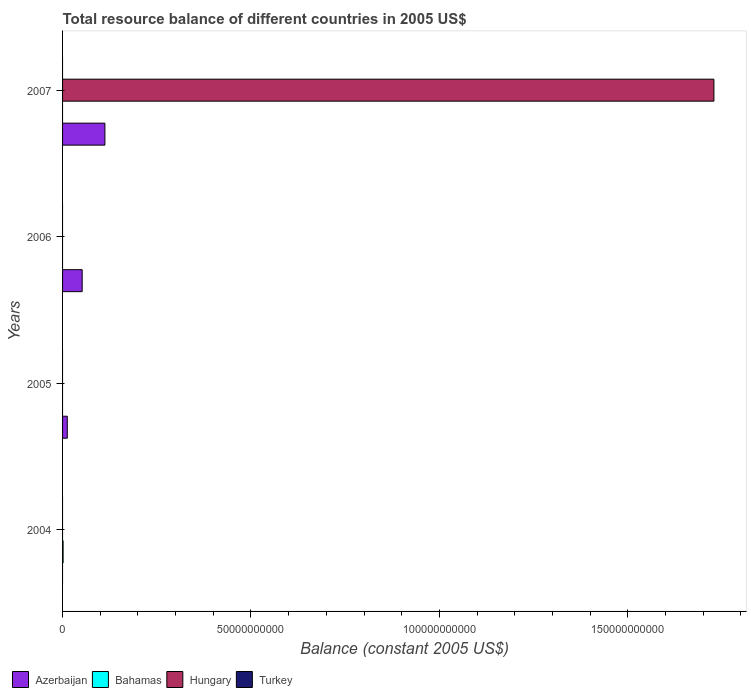How many different coloured bars are there?
Ensure brevity in your answer.  3. Are the number of bars per tick equal to the number of legend labels?
Offer a terse response. No. What is the label of the 1st group of bars from the top?
Provide a succinct answer. 2007. In how many cases, is the number of bars for a given year not equal to the number of legend labels?
Keep it short and to the point. 4. What is the total resource balance in Bahamas in 2004?
Keep it short and to the point. 1.42e+08. Across all years, what is the maximum total resource balance in Bahamas?
Give a very brief answer. 1.42e+08. What is the total total resource balance in Hungary in the graph?
Provide a short and direct response. 1.73e+11. What is the difference between the total resource balance in Azerbaijan in 2005 and that in 2007?
Provide a succinct answer. -9.98e+09. What is the difference between the total resource balance in Azerbaijan in 2004 and the total resource balance in Bahamas in 2005?
Provide a succinct answer. 0. What is the average total resource balance in Azerbaijan per year?
Give a very brief answer. 4.42e+09. In the year 2007, what is the difference between the total resource balance in Azerbaijan and total resource balance in Hungary?
Your answer should be very brief. -1.62e+11. In how many years, is the total resource balance in Azerbaijan greater than 50000000000 US$?
Your answer should be very brief. 0. What is the difference between the highest and the second highest total resource balance in Azerbaijan?
Give a very brief answer. 6.03e+09. What is the difference between the highest and the lowest total resource balance in Azerbaijan?
Your response must be concise. 1.12e+1. In how many years, is the total resource balance in Azerbaijan greater than the average total resource balance in Azerbaijan taken over all years?
Your response must be concise. 2. Is it the case that in every year, the sum of the total resource balance in Bahamas and total resource balance in Hungary is greater than the sum of total resource balance in Azerbaijan and total resource balance in Turkey?
Ensure brevity in your answer.  No. Is it the case that in every year, the sum of the total resource balance in Azerbaijan and total resource balance in Bahamas is greater than the total resource balance in Turkey?
Provide a short and direct response. Yes. Are all the bars in the graph horizontal?
Ensure brevity in your answer.  Yes. How many years are there in the graph?
Your response must be concise. 4. Are the values on the major ticks of X-axis written in scientific E-notation?
Your response must be concise. No. Does the graph contain any zero values?
Provide a succinct answer. Yes. Where does the legend appear in the graph?
Offer a very short reply. Bottom left. How many legend labels are there?
Make the answer very short. 4. How are the legend labels stacked?
Your response must be concise. Horizontal. What is the title of the graph?
Offer a very short reply. Total resource balance of different countries in 2005 US$. Does "Norway" appear as one of the legend labels in the graph?
Your answer should be compact. No. What is the label or title of the X-axis?
Offer a very short reply. Balance (constant 2005 US$). What is the Balance (constant 2005 US$) of Bahamas in 2004?
Your response must be concise. 1.42e+08. What is the Balance (constant 2005 US$) of Azerbaijan in 2005?
Provide a short and direct response. 1.26e+09. What is the Balance (constant 2005 US$) of Bahamas in 2005?
Keep it short and to the point. 0. What is the Balance (constant 2005 US$) in Hungary in 2005?
Your answer should be compact. 0. What is the Balance (constant 2005 US$) of Turkey in 2005?
Keep it short and to the point. 0. What is the Balance (constant 2005 US$) of Azerbaijan in 2006?
Your answer should be very brief. 5.20e+09. What is the Balance (constant 2005 US$) of Hungary in 2006?
Ensure brevity in your answer.  0. What is the Balance (constant 2005 US$) of Turkey in 2006?
Your answer should be very brief. 0. What is the Balance (constant 2005 US$) of Azerbaijan in 2007?
Provide a succinct answer. 1.12e+1. What is the Balance (constant 2005 US$) of Hungary in 2007?
Keep it short and to the point. 1.73e+11. What is the Balance (constant 2005 US$) in Turkey in 2007?
Offer a terse response. 0. Across all years, what is the maximum Balance (constant 2005 US$) in Azerbaijan?
Provide a short and direct response. 1.12e+1. Across all years, what is the maximum Balance (constant 2005 US$) of Bahamas?
Ensure brevity in your answer.  1.42e+08. Across all years, what is the maximum Balance (constant 2005 US$) in Hungary?
Your response must be concise. 1.73e+11. Across all years, what is the minimum Balance (constant 2005 US$) in Azerbaijan?
Your answer should be compact. 0. Across all years, what is the minimum Balance (constant 2005 US$) in Hungary?
Give a very brief answer. 0. What is the total Balance (constant 2005 US$) in Azerbaijan in the graph?
Your response must be concise. 1.77e+1. What is the total Balance (constant 2005 US$) of Bahamas in the graph?
Provide a succinct answer. 1.42e+08. What is the total Balance (constant 2005 US$) in Hungary in the graph?
Give a very brief answer. 1.73e+11. What is the total Balance (constant 2005 US$) of Turkey in the graph?
Give a very brief answer. 0. What is the difference between the Balance (constant 2005 US$) of Azerbaijan in 2005 and that in 2006?
Give a very brief answer. -3.94e+09. What is the difference between the Balance (constant 2005 US$) in Azerbaijan in 2005 and that in 2007?
Keep it short and to the point. -9.98e+09. What is the difference between the Balance (constant 2005 US$) of Azerbaijan in 2006 and that in 2007?
Your response must be concise. -6.03e+09. What is the difference between the Balance (constant 2005 US$) of Bahamas in 2004 and the Balance (constant 2005 US$) of Hungary in 2007?
Keep it short and to the point. -1.73e+11. What is the difference between the Balance (constant 2005 US$) of Azerbaijan in 2005 and the Balance (constant 2005 US$) of Hungary in 2007?
Your answer should be compact. -1.72e+11. What is the difference between the Balance (constant 2005 US$) of Azerbaijan in 2006 and the Balance (constant 2005 US$) of Hungary in 2007?
Your answer should be very brief. -1.68e+11. What is the average Balance (constant 2005 US$) in Azerbaijan per year?
Your answer should be very brief. 4.42e+09. What is the average Balance (constant 2005 US$) in Bahamas per year?
Provide a succinct answer. 3.54e+07. What is the average Balance (constant 2005 US$) of Hungary per year?
Offer a very short reply. 4.32e+1. In the year 2007, what is the difference between the Balance (constant 2005 US$) in Azerbaijan and Balance (constant 2005 US$) in Hungary?
Provide a short and direct response. -1.62e+11. What is the ratio of the Balance (constant 2005 US$) of Azerbaijan in 2005 to that in 2006?
Offer a very short reply. 0.24. What is the ratio of the Balance (constant 2005 US$) in Azerbaijan in 2005 to that in 2007?
Your response must be concise. 0.11. What is the ratio of the Balance (constant 2005 US$) of Azerbaijan in 2006 to that in 2007?
Ensure brevity in your answer.  0.46. What is the difference between the highest and the second highest Balance (constant 2005 US$) in Azerbaijan?
Keep it short and to the point. 6.03e+09. What is the difference between the highest and the lowest Balance (constant 2005 US$) in Azerbaijan?
Your answer should be very brief. 1.12e+1. What is the difference between the highest and the lowest Balance (constant 2005 US$) of Bahamas?
Give a very brief answer. 1.42e+08. What is the difference between the highest and the lowest Balance (constant 2005 US$) of Hungary?
Make the answer very short. 1.73e+11. 